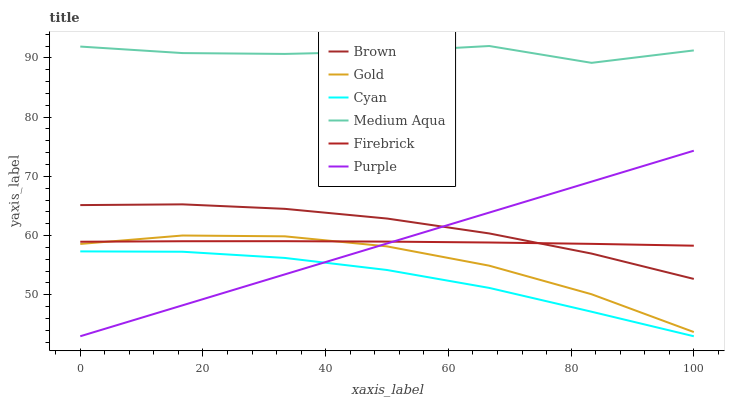Does Cyan have the minimum area under the curve?
Answer yes or no. Yes. Does Medium Aqua have the maximum area under the curve?
Answer yes or no. Yes. Does Gold have the minimum area under the curve?
Answer yes or no. No. Does Gold have the maximum area under the curve?
Answer yes or no. No. Is Purple the smoothest?
Answer yes or no. Yes. Is Medium Aqua the roughest?
Answer yes or no. Yes. Is Gold the smoothest?
Answer yes or no. No. Is Gold the roughest?
Answer yes or no. No. Does Purple have the lowest value?
Answer yes or no. Yes. Does Gold have the lowest value?
Answer yes or no. No. Does Medium Aqua have the highest value?
Answer yes or no. Yes. Does Gold have the highest value?
Answer yes or no. No. Is Gold less than Brown?
Answer yes or no. Yes. Is Medium Aqua greater than Purple?
Answer yes or no. Yes. Does Brown intersect Firebrick?
Answer yes or no. Yes. Is Brown less than Firebrick?
Answer yes or no. No. Is Brown greater than Firebrick?
Answer yes or no. No. Does Gold intersect Brown?
Answer yes or no. No. 